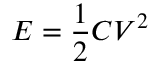Convert formula to latex. <formula><loc_0><loc_0><loc_500><loc_500>E = \frac { 1 } { 2 } C V ^ { 2 }</formula> 